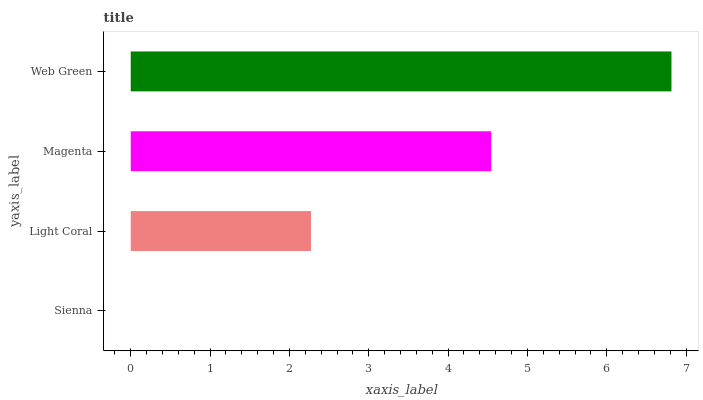Is Sienna the minimum?
Answer yes or no. Yes. Is Web Green the maximum?
Answer yes or no. Yes. Is Light Coral the minimum?
Answer yes or no. No. Is Light Coral the maximum?
Answer yes or no. No. Is Light Coral greater than Sienna?
Answer yes or no. Yes. Is Sienna less than Light Coral?
Answer yes or no. Yes. Is Sienna greater than Light Coral?
Answer yes or no. No. Is Light Coral less than Sienna?
Answer yes or no. No. Is Magenta the high median?
Answer yes or no. Yes. Is Light Coral the low median?
Answer yes or no. Yes. Is Light Coral the high median?
Answer yes or no. No. Is Magenta the low median?
Answer yes or no. No. 